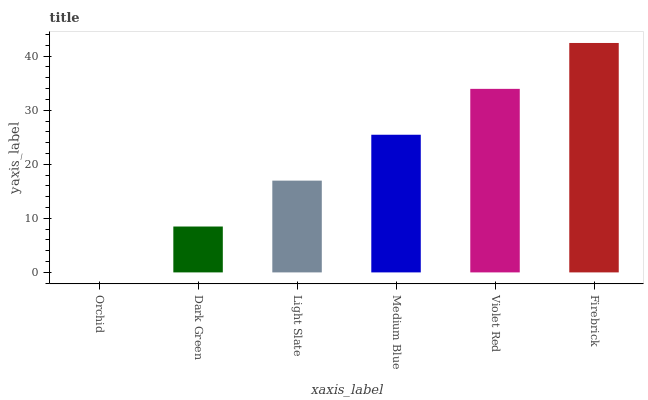Is Orchid the minimum?
Answer yes or no. Yes. Is Firebrick the maximum?
Answer yes or no. Yes. Is Dark Green the minimum?
Answer yes or no. No. Is Dark Green the maximum?
Answer yes or no. No. Is Dark Green greater than Orchid?
Answer yes or no. Yes. Is Orchid less than Dark Green?
Answer yes or no. Yes. Is Orchid greater than Dark Green?
Answer yes or no. No. Is Dark Green less than Orchid?
Answer yes or no. No. Is Medium Blue the high median?
Answer yes or no. Yes. Is Light Slate the low median?
Answer yes or no. Yes. Is Dark Green the high median?
Answer yes or no. No. Is Firebrick the low median?
Answer yes or no. No. 